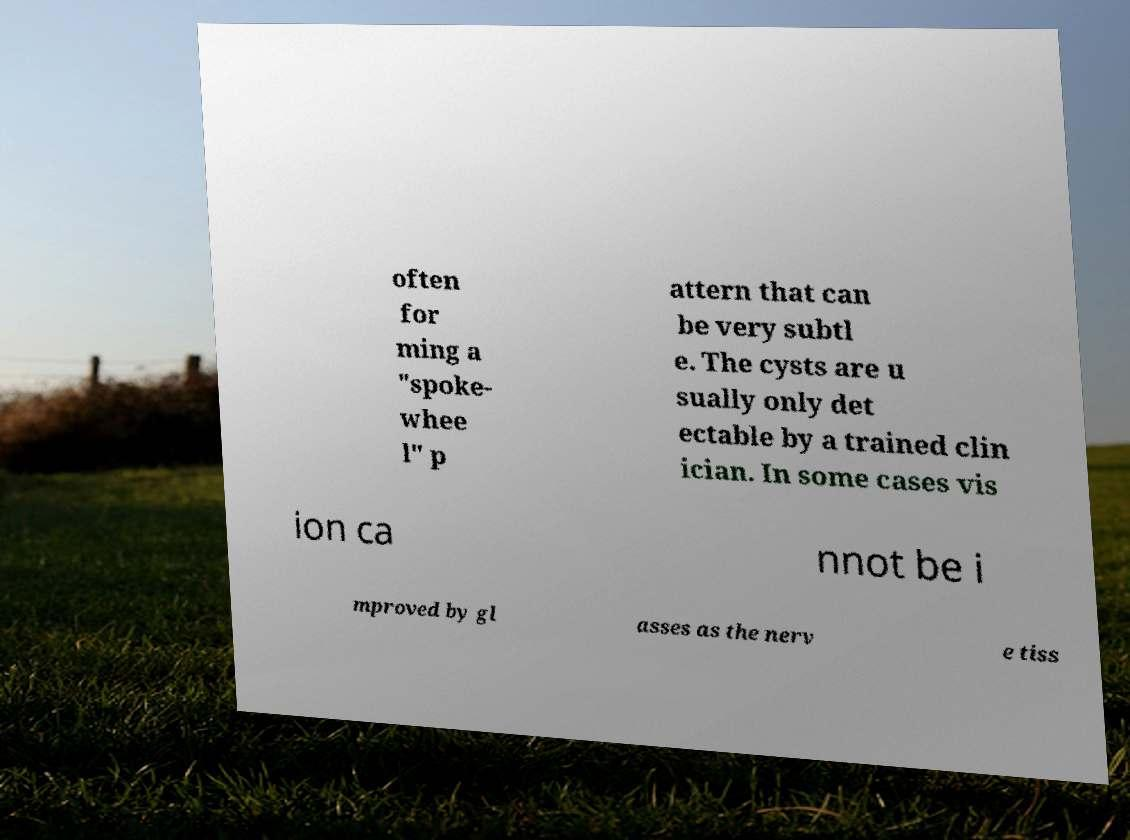For documentation purposes, I need the text within this image transcribed. Could you provide that? often for ming a "spoke- whee l" p attern that can be very subtl e. The cysts are u sually only det ectable by a trained clin ician. In some cases vis ion ca nnot be i mproved by gl asses as the nerv e tiss 